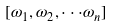Convert formula to latex. <formula><loc_0><loc_0><loc_500><loc_500>[ \omega _ { 1 } , \omega _ { 2 } , \cdot \cdot \cdot \omega _ { n } ]</formula> 